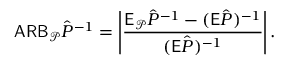Convert formula to latex. <formula><loc_0><loc_0><loc_500><loc_500>A R B _ { \mathcal { P } } \hat { P } ^ { - 1 } = \left | \frac { \mathsf E _ { \mathcal { P } } \hat { P } ^ { - 1 } - ( \mathsf E \hat { P } ) ^ { - 1 } } { ( \mathsf E \hat { P } ) ^ { - 1 } } \right | .</formula> 